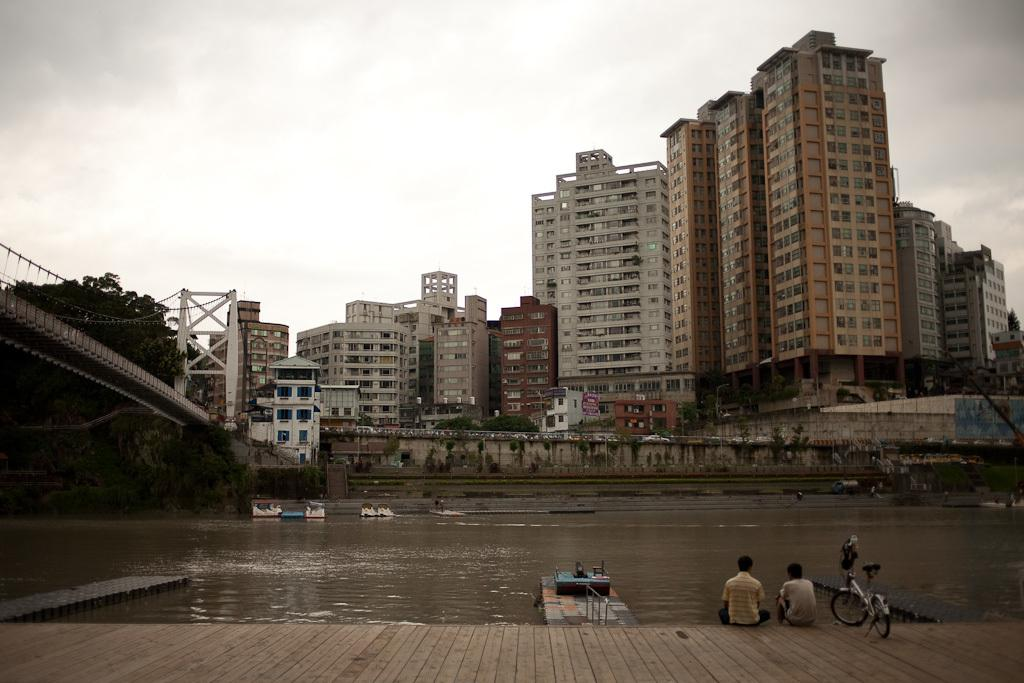What type of natural feature is present in the image? There is a river in the image. How is the river positioned in relation to the bridge? The river is under a bridge. Can you describe the people in the image? There are 2 people sitting on a wooden surface. What can be seen in the distance in the image? There are buildings visible in the background of the image. What type of songs can be heard coming from the ducks in the image? There are no ducks present in the image, so it's not possible to determine what, if any, songs might be heard. 